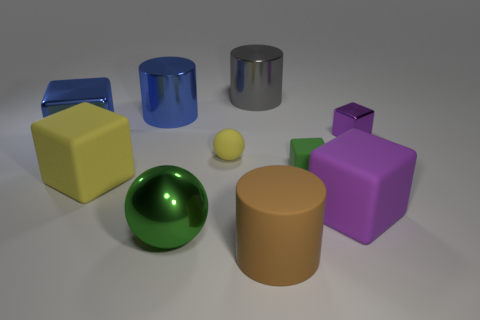Subtract 1 cubes. How many cubes are left? 4 Subtract all blue cubes. How many cubes are left? 4 Subtract all brown cubes. Subtract all gray spheres. How many cubes are left? 5 Subtract all cylinders. How many objects are left? 7 Subtract all big red matte objects. Subtract all big metallic objects. How many objects are left? 6 Add 3 big yellow cubes. How many big yellow cubes are left? 4 Add 7 blue metallic cubes. How many blue metallic cubes exist? 8 Subtract 0 yellow cylinders. How many objects are left? 10 